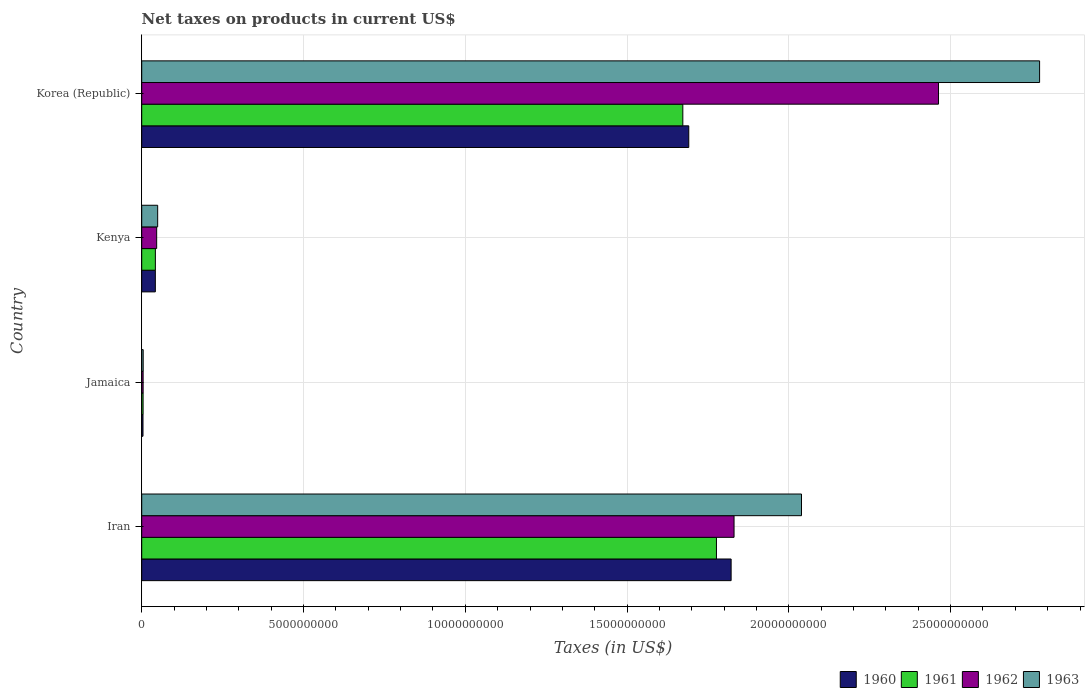Are the number of bars on each tick of the Y-axis equal?
Keep it short and to the point. Yes. How many bars are there on the 2nd tick from the top?
Your answer should be very brief. 4. What is the label of the 3rd group of bars from the top?
Ensure brevity in your answer.  Jamaica. What is the net taxes on products in 1961 in Iran?
Keep it short and to the point. 1.78e+1. Across all countries, what is the maximum net taxes on products in 1963?
Give a very brief answer. 2.77e+1. Across all countries, what is the minimum net taxes on products in 1960?
Your answer should be very brief. 3.93e+07. In which country was the net taxes on products in 1963 maximum?
Your answer should be compact. Korea (Republic). In which country was the net taxes on products in 1961 minimum?
Offer a terse response. Jamaica. What is the total net taxes on products in 1960 in the graph?
Offer a terse response. 3.56e+1. What is the difference between the net taxes on products in 1961 in Iran and that in Jamaica?
Give a very brief answer. 1.77e+1. What is the difference between the net taxes on products in 1963 in Kenya and the net taxes on products in 1961 in Iran?
Offer a very short reply. -1.73e+1. What is the average net taxes on products in 1961 per country?
Ensure brevity in your answer.  8.74e+09. What is the difference between the net taxes on products in 1961 and net taxes on products in 1963 in Iran?
Keep it short and to the point. -2.63e+09. What is the ratio of the net taxes on products in 1960 in Iran to that in Jamaica?
Keep it short and to the point. 463.51. Is the difference between the net taxes on products in 1961 in Iran and Jamaica greater than the difference between the net taxes on products in 1963 in Iran and Jamaica?
Make the answer very short. No. What is the difference between the highest and the second highest net taxes on products in 1960?
Offer a very short reply. 1.31e+09. What is the difference between the highest and the lowest net taxes on products in 1961?
Provide a short and direct response. 1.77e+1. In how many countries, is the net taxes on products in 1962 greater than the average net taxes on products in 1962 taken over all countries?
Provide a short and direct response. 2. Is the sum of the net taxes on products in 1961 in Iran and Korea (Republic) greater than the maximum net taxes on products in 1960 across all countries?
Provide a short and direct response. Yes. What does the 3rd bar from the top in Iran represents?
Ensure brevity in your answer.  1961. How many bars are there?
Provide a short and direct response. 16. How many countries are there in the graph?
Ensure brevity in your answer.  4. What is the difference between two consecutive major ticks on the X-axis?
Your response must be concise. 5.00e+09. Does the graph contain any zero values?
Provide a succinct answer. No. Does the graph contain grids?
Your answer should be very brief. Yes. How many legend labels are there?
Offer a very short reply. 4. What is the title of the graph?
Ensure brevity in your answer.  Net taxes on products in current US$. What is the label or title of the X-axis?
Your answer should be compact. Taxes (in US$). What is the Taxes (in US$) in 1960 in Iran?
Offer a very short reply. 1.82e+1. What is the Taxes (in US$) of 1961 in Iran?
Provide a succinct answer. 1.78e+1. What is the Taxes (in US$) of 1962 in Iran?
Offer a terse response. 1.83e+1. What is the Taxes (in US$) of 1963 in Iran?
Give a very brief answer. 2.04e+1. What is the Taxes (in US$) of 1960 in Jamaica?
Offer a terse response. 3.93e+07. What is the Taxes (in US$) in 1961 in Jamaica?
Provide a short and direct response. 4.26e+07. What is the Taxes (in US$) of 1962 in Jamaica?
Ensure brevity in your answer.  4.35e+07. What is the Taxes (in US$) in 1963 in Jamaica?
Give a very brief answer. 4.54e+07. What is the Taxes (in US$) in 1960 in Kenya?
Your response must be concise. 4.21e+08. What is the Taxes (in US$) of 1961 in Kenya?
Your answer should be compact. 4.22e+08. What is the Taxes (in US$) in 1962 in Kenya?
Provide a short and direct response. 4.62e+08. What is the Taxes (in US$) of 1963 in Kenya?
Offer a very short reply. 4.93e+08. What is the Taxes (in US$) in 1960 in Korea (Republic)?
Your answer should be compact. 1.69e+1. What is the Taxes (in US$) of 1961 in Korea (Republic)?
Your answer should be very brief. 1.67e+1. What is the Taxes (in US$) in 1962 in Korea (Republic)?
Offer a terse response. 2.46e+1. What is the Taxes (in US$) of 1963 in Korea (Republic)?
Your answer should be very brief. 2.77e+1. Across all countries, what is the maximum Taxes (in US$) in 1960?
Keep it short and to the point. 1.82e+1. Across all countries, what is the maximum Taxes (in US$) in 1961?
Your answer should be very brief. 1.78e+1. Across all countries, what is the maximum Taxes (in US$) in 1962?
Make the answer very short. 2.46e+1. Across all countries, what is the maximum Taxes (in US$) in 1963?
Offer a terse response. 2.77e+1. Across all countries, what is the minimum Taxes (in US$) of 1960?
Your answer should be compact. 3.93e+07. Across all countries, what is the minimum Taxes (in US$) in 1961?
Give a very brief answer. 4.26e+07. Across all countries, what is the minimum Taxes (in US$) in 1962?
Your response must be concise. 4.35e+07. Across all countries, what is the minimum Taxes (in US$) in 1963?
Your response must be concise. 4.54e+07. What is the total Taxes (in US$) of 1960 in the graph?
Provide a short and direct response. 3.56e+1. What is the total Taxes (in US$) of 1961 in the graph?
Provide a short and direct response. 3.50e+1. What is the total Taxes (in US$) in 1962 in the graph?
Provide a short and direct response. 4.34e+1. What is the total Taxes (in US$) in 1963 in the graph?
Offer a terse response. 4.87e+1. What is the difference between the Taxes (in US$) in 1960 in Iran and that in Jamaica?
Your response must be concise. 1.82e+1. What is the difference between the Taxes (in US$) in 1961 in Iran and that in Jamaica?
Your answer should be compact. 1.77e+1. What is the difference between the Taxes (in US$) of 1962 in Iran and that in Jamaica?
Give a very brief answer. 1.83e+1. What is the difference between the Taxes (in US$) of 1963 in Iran and that in Jamaica?
Make the answer very short. 2.03e+1. What is the difference between the Taxes (in US$) of 1960 in Iran and that in Kenya?
Ensure brevity in your answer.  1.78e+1. What is the difference between the Taxes (in US$) of 1961 in Iran and that in Kenya?
Offer a terse response. 1.73e+1. What is the difference between the Taxes (in US$) in 1962 in Iran and that in Kenya?
Make the answer very short. 1.78e+1. What is the difference between the Taxes (in US$) of 1963 in Iran and that in Kenya?
Keep it short and to the point. 1.99e+1. What is the difference between the Taxes (in US$) in 1960 in Iran and that in Korea (Republic)?
Give a very brief answer. 1.31e+09. What is the difference between the Taxes (in US$) in 1961 in Iran and that in Korea (Republic)?
Offer a very short reply. 1.04e+09. What is the difference between the Taxes (in US$) in 1962 in Iran and that in Korea (Republic)?
Your answer should be very brief. -6.32e+09. What is the difference between the Taxes (in US$) of 1963 in Iran and that in Korea (Republic)?
Provide a short and direct response. -7.36e+09. What is the difference between the Taxes (in US$) in 1960 in Jamaica and that in Kenya?
Your response must be concise. -3.82e+08. What is the difference between the Taxes (in US$) of 1961 in Jamaica and that in Kenya?
Make the answer very short. -3.79e+08. What is the difference between the Taxes (in US$) of 1962 in Jamaica and that in Kenya?
Provide a short and direct response. -4.18e+08. What is the difference between the Taxes (in US$) in 1963 in Jamaica and that in Kenya?
Offer a very short reply. -4.48e+08. What is the difference between the Taxes (in US$) in 1960 in Jamaica and that in Korea (Republic)?
Make the answer very short. -1.69e+1. What is the difference between the Taxes (in US$) in 1961 in Jamaica and that in Korea (Republic)?
Provide a short and direct response. -1.67e+1. What is the difference between the Taxes (in US$) of 1962 in Jamaica and that in Korea (Republic)?
Your response must be concise. -2.46e+1. What is the difference between the Taxes (in US$) of 1963 in Jamaica and that in Korea (Republic)?
Provide a succinct answer. -2.77e+1. What is the difference between the Taxes (in US$) in 1960 in Kenya and that in Korea (Republic)?
Your answer should be very brief. -1.65e+1. What is the difference between the Taxes (in US$) of 1961 in Kenya and that in Korea (Republic)?
Make the answer very short. -1.63e+1. What is the difference between the Taxes (in US$) in 1962 in Kenya and that in Korea (Republic)?
Keep it short and to the point. -2.42e+1. What is the difference between the Taxes (in US$) of 1963 in Kenya and that in Korea (Republic)?
Your response must be concise. -2.73e+1. What is the difference between the Taxes (in US$) in 1960 in Iran and the Taxes (in US$) in 1961 in Jamaica?
Your answer should be compact. 1.82e+1. What is the difference between the Taxes (in US$) of 1960 in Iran and the Taxes (in US$) of 1962 in Jamaica?
Provide a short and direct response. 1.82e+1. What is the difference between the Taxes (in US$) in 1960 in Iran and the Taxes (in US$) in 1963 in Jamaica?
Your response must be concise. 1.82e+1. What is the difference between the Taxes (in US$) of 1961 in Iran and the Taxes (in US$) of 1962 in Jamaica?
Your response must be concise. 1.77e+1. What is the difference between the Taxes (in US$) of 1961 in Iran and the Taxes (in US$) of 1963 in Jamaica?
Provide a short and direct response. 1.77e+1. What is the difference between the Taxes (in US$) of 1962 in Iran and the Taxes (in US$) of 1963 in Jamaica?
Ensure brevity in your answer.  1.83e+1. What is the difference between the Taxes (in US$) of 1960 in Iran and the Taxes (in US$) of 1961 in Kenya?
Your answer should be compact. 1.78e+1. What is the difference between the Taxes (in US$) of 1960 in Iran and the Taxes (in US$) of 1962 in Kenya?
Your answer should be very brief. 1.78e+1. What is the difference between the Taxes (in US$) in 1960 in Iran and the Taxes (in US$) in 1963 in Kenya?
Your response must be concise. 1.77e+1. What is the difference between the Taxes (in US$) in 1961 in Iran and the Taxes (in US$) in 1962 in Kenya?
Make the answer very short. 1.73e+1. What is the difference between the Taxes (in US$) in 1961 in Iran and the Taxes (in US$) in 1963 in Kenya?
Offer a terse response. 1.73e+1. What is the difference between the Taxes (in US$) of 1962 in Iran and the Taxes (in US$) of 1963 in Kenya?
Your answer should be compact. 1.78e+1. What is the difference between the Taxes (in US$) of 1960 in Iran and the Taxes (in US$) of 1961 in Korea (Republic)?
Your answer should be very brief. 1.49e+09. What is the difference between the Taxes (in US$) of 1960 in Iran and the Taxes (in US$) of 1962 in Korea (Republic)?
Ensure brevity in your answer.  -6.41e+09. What is the difference between the Taxes (in US$) of 1960 in Iran and the Taxes (in US$) of 1963 in Korea (Republic)?
Provide a succinct answer. -9.53e+09. What is the difference between the Taxes (in US$) of 1961 in Iran and the Taxes (in US$) of 1962 in Korea (Republic)?
Keep it short and to the point. -6.86e+09. What is the difference between the Taxes (in US$) of 1961 in Iran and the Taxes (in US$) of 1963 in Korea (Republic)?
Make the answer very short. -9.99e+09. What is the difference between the Taxes (in US$) of 1962 in Iran and the Taxes (in US$) of 1963 in Korea (Republic)?
Your response must be concise. -9.44e+09. What is the difference between the Taxes (in US$) of 1960 in Jamaica and the Taxes (in US$) of 1961 in Kenya?
Make the answer very short. -3.83e+08. What is the difference between the Taxes (in US$) of 1960 in Jamaica and the Taxes (in US$) of 1962 in Kenya?
Your response must be concise. -4.22e+08. What is the difference between the Taxes (in US$) in 1960 in Jamaica and the Taxes (in US$) in 1963 in Kenya?
Your answer should be very brief. -4.54e+08. What is the difference between the Taxes (in US$) in 1961 in Jamaica and the Taxes (in US$) in 1962 in Kenya?
Offer a terse response. -4.19e+08. What is the difference between the Taxes (in US$) of 1961 in Jamaica and the Taxes (in US$) of 1963 in Kenya?
Your answer should be very brief. -4.50e+08. What is the difference between the Taxes (in US$) of 1962 in Jamaica and the Taxes (in US$) of 1963 in Kenya?
Provide a short and direct response. -4.50e+08. What is the difference between the Taxes (in US$) of 1960 in Jamaica and the Taxes (in US$) of 1961 in Korea (Republic)?
Give a very brief answer. -1.67e+1. What is the difference between the Taxes (in US$) of 1960 in Jamaica and the Taxes (in US$) of 1962 in Korea (Republic)?
Give a very brief answer. -2.46e+1. What is the difference between the Taxes (in US$) in 1960 in Jamaica and the Taxes (in US$) in 1963 in Korea (Republic)?
Provide a short and direct response. -2.77e+1. What is the difference between the Taxes (in US$) of 1961 in Jamaica and the Taxes (in US$) of 1962 in Korea (Republic)?
Your answer should be compact. -2.46e+1. What is the difference between the Taxes (in US$) in 1961 in Jamaica and the Taxes (in US$) in 1963 in Korea (Republic)?
Provide a short and direct response. -2.77e+1. What is the difference between the Taxes (in US$) of 1962 in Jamaica and the Taxes (in US$) of 1963 in Korea (Republic)?
Offer a terse response. -2.77e+1. What is the difference between the Taxes (in US$) of 1960 in Kenya and the Taxes (in US$) of 1961 in Korea (Republic)?
Make the answer very short. -1.63e+1. What is the difference between the Taxes (in US$) of 1960 in Kenya and the Taxes (in US$) of 1962 in Korea (Republic)?
Provide a succinct answer. -2.42e+1. What is the difference between the Taxes (in US$) of 1960 in Kenya and the Taxes (in US$) of 1963 in Korea (Republic)?
Your response must be concise. -2.73e+1. What is the difference between the Taxes (in US$) of 1961 in Kenya and the Taxes (in US$) of 1962 in Korea (Republic)?
Provide a succinct answer. -2.42e+1. What is the difference between the Taxes (in US$) of 1961 in Kenya and the Taxes (in US$) of 1963 in Korea (Republic)?
Your response must be concise. -2.73e+1. What is the difference between the Taxes (in US$) of 1962 in Kenya and the Taxes (in US$) of 1963 in Korea (Republic)?
Your answer should be very brief. -2.73e+1. What is the average Taxes (in US$) in 1960 per country?
Your answer should be very brief. 8.90e+09. What is the average Taxes (in US$) of 1961 per country?
Provide a succinct answer. 8.74e+09. What is the average Taxes (in US$) in 1962 per country?
Offer a terse response. 1.09e+1. What is the average Taxes (in US$) in 1963 per country?
Offer a very short reply. 1.22e+1. What is the difference between the Taxes (in US$) in 1960 and Taxes (in US$) in 1961 in Iran?
Give a very brief answer. 4.53e+08. What is the difference between the Taxes (in US$) of 1960 and Taxes (in US$) of 1962 in Iran?
Offer a very short reply. -9.06e+07. What is the difference between the Taxes (in US$) of 1960 and Taxes (in US$) of 1963 in Iran?
Your answer should be compact. -2.18e+09. What is the difference between the Taxes (in US$) in 1961 and Taxes (in US$) in 1962 in Iran?
Your response must be concise. -5.44e+08. What is the difference between the Taxes (in US$) in 1961 and Taxes (in US$) in 1963 in Iran?
Offer a very short reply. -2.63e+09. What is the difference between the Taxes (in US$) of 1962 and Taxes (in US$) of 1963 in Iran?
Give a very brief answer. -2.08e+09. What is the difference between the Taxes (in US$) in 1960 and Taxes (in US$) in 1961 in Jamaica?
Your answer should be very brief. -3.30e+06. What is the difference between the Taxes (in US$) of 1960 and Taxes (in US$) of 1962 in Jamaica?
Provide a succinct answer. -4.20e+06. What is the difference between the Taxes (in US$) of 1960 and Taxes (in US$) of 1963 in Jamaica?
Provide a succinct answer. -6.10e+06. What is the difference between the Taxes (in US$) of 1961 and Taxes (in US$) of 1962 in Jamaica?
Provide a short and direct response. -9.00e+05. What is the difference between the Taxes (in US$) of 1961 and Taxes (in US$) of 1963 in Jamaica?
Ensure brevity in your answer.  -2.80e+06. What is the difference between the Taxes (in US$) in 1962 and Taxes (in US$) in 1963 in Jamaica?
Your answer should be compact. -1.90e+06. What is the difference between the Taxes (in US$) of 1960 and Taxes (in US$) of 1962 in Kenya?
Ensure brevity in your answer.  -4.09e+07. What is the difference between the Taxes (in US$) in 1960 and Taxes (in US$) in 1963 in Kenya?
Provide a short and direct response. -7.21e+07. What is the difference between the Taxes (in US$) in 1961 and Taxes (in US$) in 1962 in Kenya?
Provide a succinct answer. -3.99e+07. What is the difference between the Taxes (in US$) of 1961 and Taxes (in US$) of 1963 in Kenya?
Make the answer very short. -7.11e+07. What is the difference between the Taxes (in US$) of 1962 and Taxes (in US$) of 1963 in Kenya?
Provide a short and direct response. -3.12e+07. What is the difference between the Taxes (in US$) of 1960 and Taxes (in US$) of 1961 in Korea (Republic)?
Your answer should be compact. 1.84e+08. What is the difference between the Taxes (in US$) in 1960 and Taxes (in US$) in 1962 in Korea (Republic)?
Your response must be concise. -7.72e+09. What is the difference between the Taxes (in US$) in 1960 and Taxes (in US$) in 1963 in Korea (Republic)?
Your response must be concise. -1.08e+1. What is the difference between the Taxes (in US$) of 1961 and Taxes (in US$) of 1962 in Korea (Republic)?
Provide a short and direct response. -7.90e+09. What is the difference between the Taxes (in US$) in 1961 and Taxes (in US$) in 1963 in Korea (Republic)?
Provide a short and direct response. -1.10e+1. What is the difference between the Taxes (in US$) of 1962 and Taxes (in US$) of 1963 in Korea (Republic)?
Provide a succinct answer. -3.12e+09. What is the ratio of the Taxes (in US$) in 1960 in Iran to that in Jamaica?
Your answer should be compact. 463.51. What is the ratio of the Taxes (in US$) in 1961 in Iran to that in Jamaica?
Ensure brevity in your answer.  416.97. What is the ratio of the Taxes (in US$) of 1962 in Iran to that in Jamaica?
Offer a very short reply. 420.84. What is the ratio of the Taxes (in US$) in 1963 in Iran to that in Jamaica?
Make the answer very short. 449.14. What is the ratio of the Taxes (in US$) in 1960 in Iran to that in Kenya?
Ensure brevity in your answer.  43.28. What is the ratio of the Taxes (in US$) of 1961 in Iran to that in Kenya?
Offer a terse response. 42.1. What is the ratio of the Taxes (in US$) of 1962 in Iran to that in Kenya?
Your response must be concise. 39.64. What is the ratio of the Taxes (in US$) of 1963 in Iran to that in Kenya?
Provide a succinct answer. 41.36. What is the ratio of the Taxes (in US$) in 1960 in Iran to that in Korea (Republic)?
Offer a terse response. 1.08. What is the ratio of the Taxes (in US$) of 1961 in Iran to that in Korea (Republic)?
Provide a short and direct response. 1.06. What is the ratio of the Taxes (in US$) of 1962 in Iran to that in Korea (Republic)?
Your answer should be very brief. 0.74. What is the ratio of the Taxes (in US$) of 1963 in Iran to that in Korea (Republic)?
Keep it short and to the point. 0.73. What is the ratio of the Taxes (in US$) in 1960 in Jamaica to that in Kenya?
Your answer should be compact. 0.09. What is the ratio of the Taxes (in US$) of 1961 in Jamaica to that in Kenya?
Make the answer very short. 0.1. What is the ratio of the Taxes (in US$) of 1962 in Jamaica to that in Kenya?
Your answer should be compact. 0.09. What is the ratio of the Taxes (in US$) in 1963 in Jamaica to that in Kenya?
Your response must be concise. 0.09. What is the ratio of the Taxes (in US$) in 1960 in Jamaica to that in Korea (Republic)?
Offer a very short reply. 0. What is the ratio of the Taxes (in US$) of 1961 in Jamaica to that in Korea (Republic)?
Offer a terse response. 0. What is the ratio of the Taxes (in US$) in 1962 in Jamaica to that in Korea (Republic)?
Provide a succinct answer. 0. What is the ratio of the Taxes (in US$) in 1963 in Jamaica to that in Korea (Republic)?
Offer a very short reply. 0. What is the ratio of the Taxes (in US$) in 1960 in Kenya to that in Korea (Republic)?
Provide a succinct answer. 0.02. What is the ratio of the Taxes (in US$) of 1961 in Kenya to that in Korea (Republic)?
Your answer should be compact. 0.03. What is the ratio of the Taxes (in US$) of 1962 in Kenya to that in Korea (Republic)?
Your answer should be compact. 0.02. What is the ratio of the Taxes (in US$) in 1963 in Kenya to that in Korea (Republic)?
Offer a very short reply. 0.02. What is the difference between the highest and the second highest Taxes (in US$) of 1960?
Your response must be concise. 1.31e+09. What is the difference between the highest and the second highest Taxes (in US$) of 1961?
Give a very brief answer. 1.04e+09. What is the difference between the highest and the second highest Taxes (in US$) in 1962?
Make the answer very short. 6.32e+09. What is the difference between the highest and the second highest Taxes (in US$) of 1963?
Ensure brevity in your answer.  7.36e+09. What is the difference between the highest and the lowest Taxes (in US$) in 1960?
Your answer should be compact. 1.82e+1. What is the difference between the highest and the lowest Taxes (in US$) in 1961?
Offer a terse response. 1.77e+1. What is the difference between the highest and the lowest Taxes (in US$) in 1962?
Provide a short and direct response. 2.46e+1. What is the difference between the highest and the lowest Taxes (in US$) of 1963?
Your answer should be very brief. 2.77e+1. 